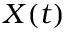<formula> <loc_0><loc_0><loc_500><loc_500>X ( t )</formula> 